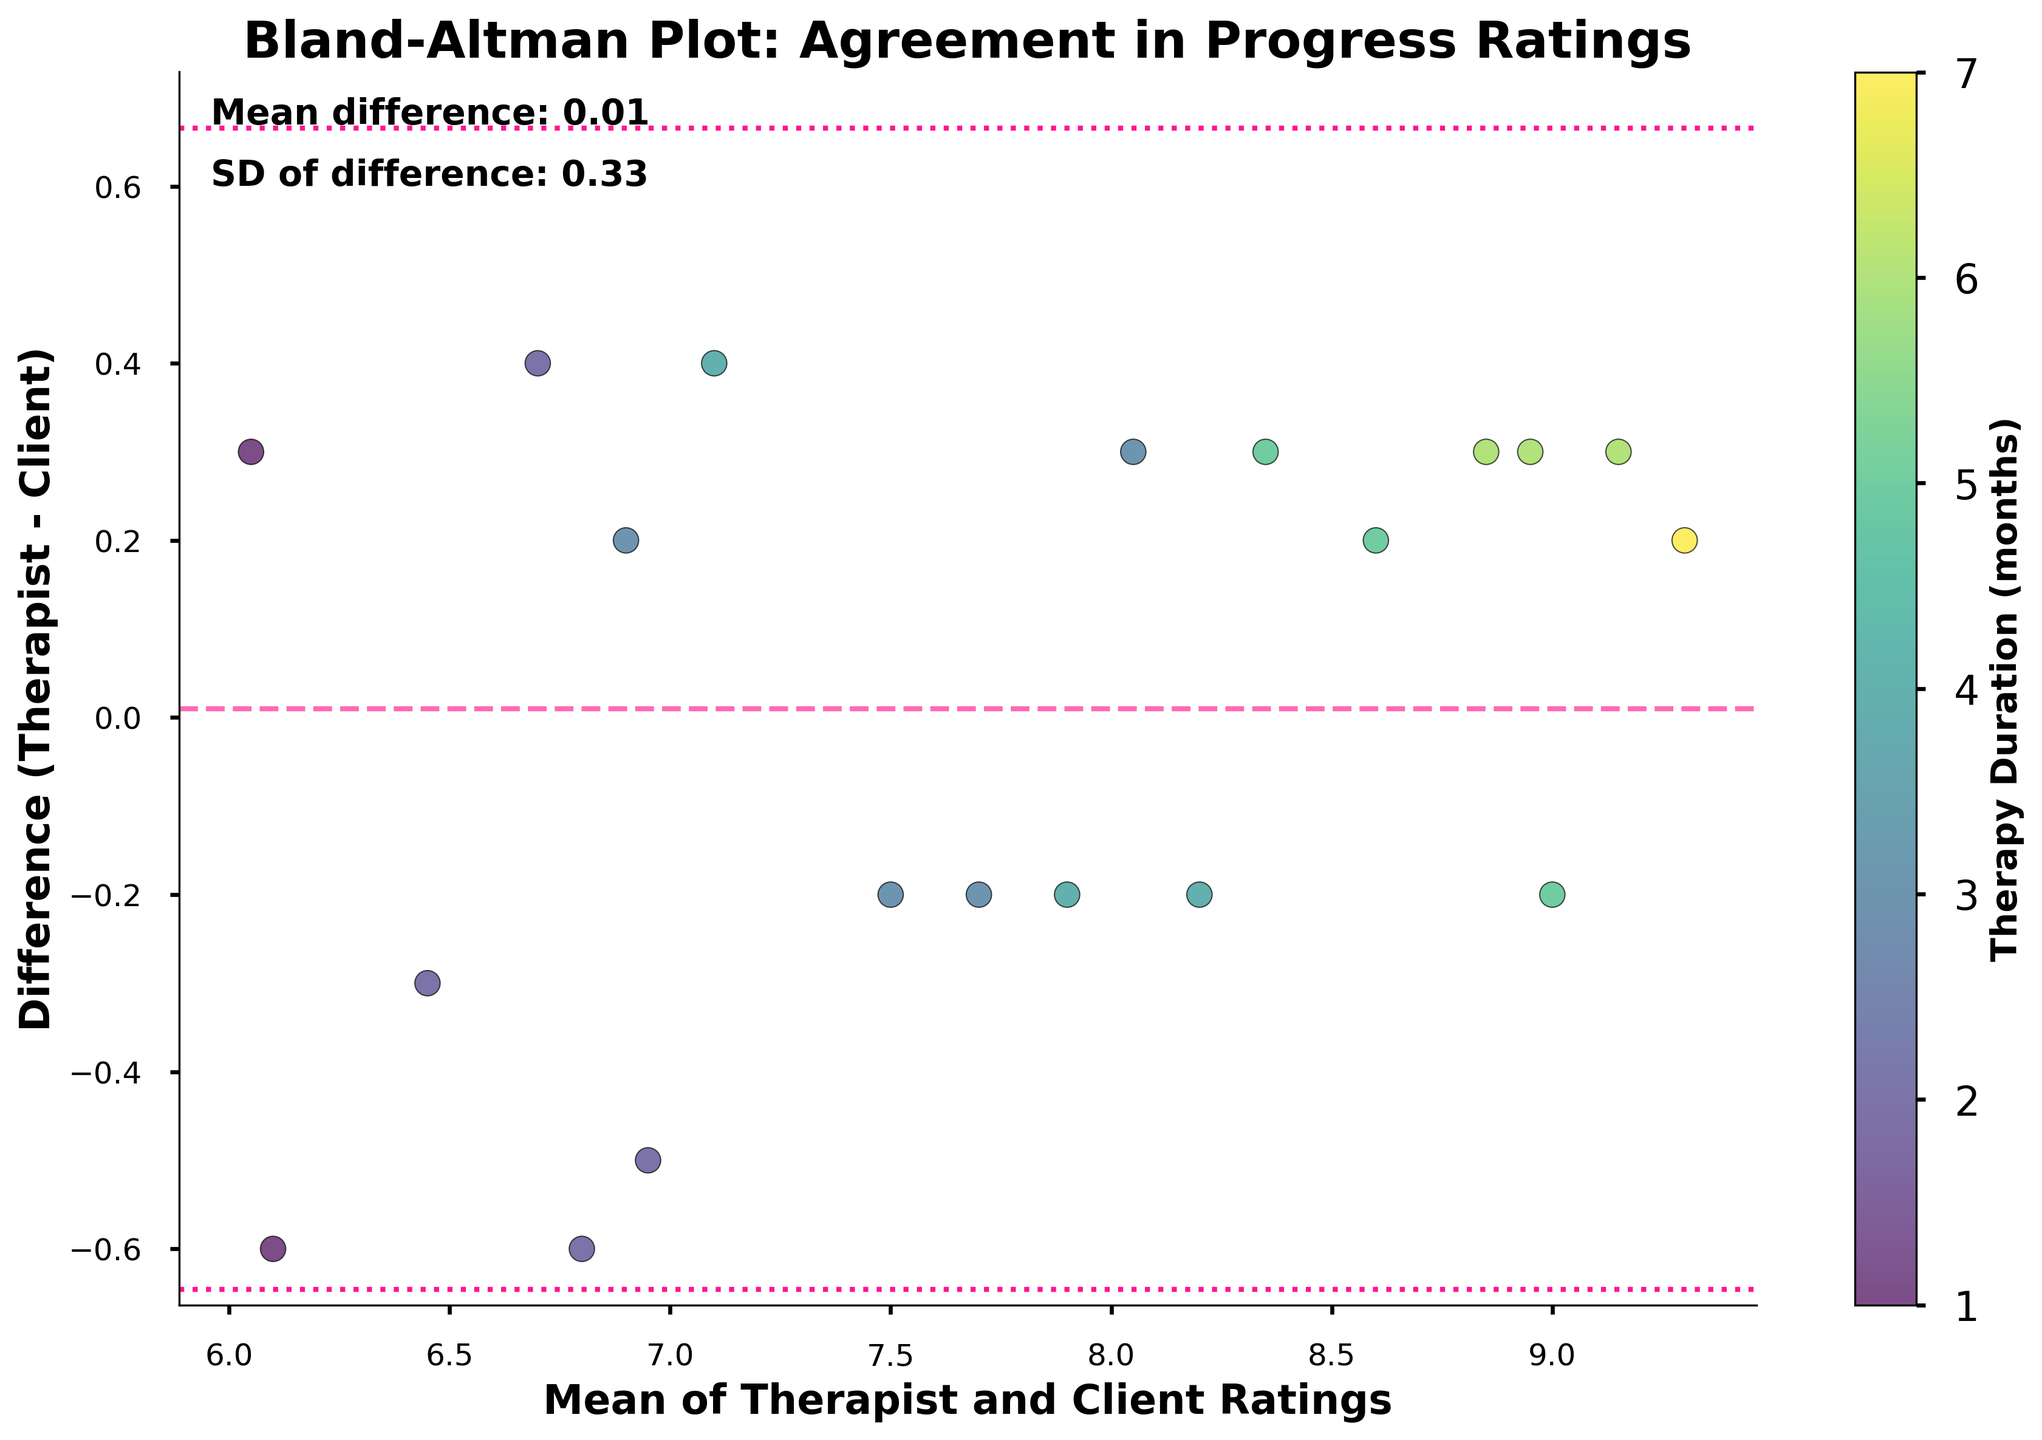What is the title of the figure? The title is typically located at the top of the figure, and it summarizes the main topic or subject of the figure. In this case, the title is "Bland-Altman Plot: Agreement in Progress Ratings."
Answer: Bland-Altman Plot: Agreement in Progress Ratings What are the axes labels in the figure, and what do they indicate? The labels on the axes explain what each axis represents. The x-axis is labeled "Mean of Therapist and Client Ratings," indicating it shows the average of the ratings by the therapist and client. The y-axis is labeled "Difference (Therapist - Client)," showing the differences between the therapist and client ratings.
Answer: X-axis: Mean of Therapist and Client Ratings, Y-axis: Difference (Therapist - Client) What do the colors of the data points represent? The plot includes a color bar labeled "Therapy Duration (months)" that helps interpret the colors. The different colors of the data points indicate the length of therapy duration with darker colors representing shorter durations and lighter colors representing longer durations.
Answer: Therapy duration in months How is the mean difference represented in the plot? The mean difference is depicted using a horizontal dashed line. This line is colored pink and runs parallel to the x-axis at the value of the mean difference. The value is also indicated in the text "Mean difference: 0.07" on the plot.
Answer: A pink dashed line What are the lines indicating 1.96 standard deviations from the mean, and what do they represent? There are two dotted lines shown in the figure, one above and one below the mean difference line. They represent the limits of agreement, which are calculated as the mean difference ± 1.96 times the standard deviation. These lines are colored dark pink.
Answer: Limits of agreement Which therapy duration is associated with the most significant positive difference between therapist and client ratings? To determine this, we need to find the data point that has the highest positive difference on the y-axis and then look at its color to determine the corresponding therapy duration. The highest positive difference is around 1.0, and the corresponding color indicates a therapy duration of 1 month.
Answer: 1 month In which therapy duration do therapist and client ratings show the least disagreement? The least disagreement means the differences are closest to zero. We look for data points near the y=0 line and check their colors. Many points around the zero difference are from therapies of various durations, but notably, we see several in the mid-range therapy durations (4-5 months).
Answer: 4-5 months What does the spread of the data points along the y-axis suggest about the agreement between therapist and client ratings? The spread of data points along the y-axis indicates the variability in differences between therapist and client ratings. A wider spread suggests higher variability and less agreement, while a narrower spread suggests lower variability and better agreement. In this figure, the spread shows moderate variability, indicating some level of disagreement.
Answer: Indicates moderate variability Which data point has the biggest negative difference, and what therapy duration does it correspond to? The biggest negative difference can be identified by finding the lowest point on the y-axis. This point has a negative difference close to around -0.8. The corresponding color for this data point likely indicates a therapy duration of 6 months.
Answer: 6 months What value is closest to the mean difference line, and what can be inferred about the agreement for these ratings? The data points closest to the mean difference line exhibit the smallest differences between therapist and client ratings, implying good agreement. These points generally have small differences near 0, indicating strong agreement between ratings. Multiple points appear close to this line, suggesting overall positive agreement.
Answer: Small differences, strong agreement 